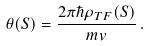<formula> <loc_0><loc_0><loc_500><loc_500>\theta ( S ) = \frac { 2 \pi \hbar { \rho } _ { T F } ( S ) } { m v } \, .</formula> 